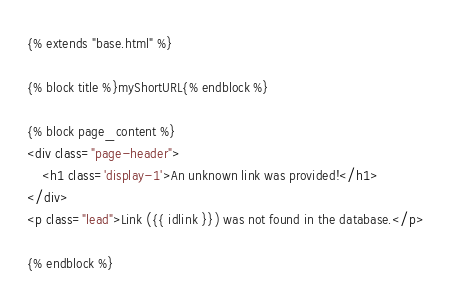Convert code to text. <code><loc_0><loc_0><loc_500><loc_500><_HTML_>{% extends "base.html" %}

{% block title %}myShortURL{% endblock %}

{% block page_content %}
<div class="page-header">
    <h1 class='display-1'>An unknown link was provided!</h1>
</div>
<p class="lead">Link ({{ idlink }}) was not found in the database.</p>

{% endblock %}</code> 